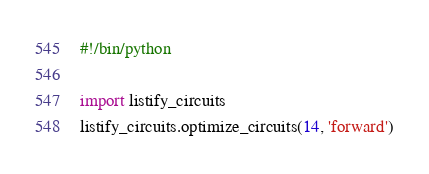<code> <loc_0><loc_0><loc_500><loc_500><_Python_>#!/bin/python

import listify_circuits
listify_circuits.optimize_circuits(14, 'forward')</code> 